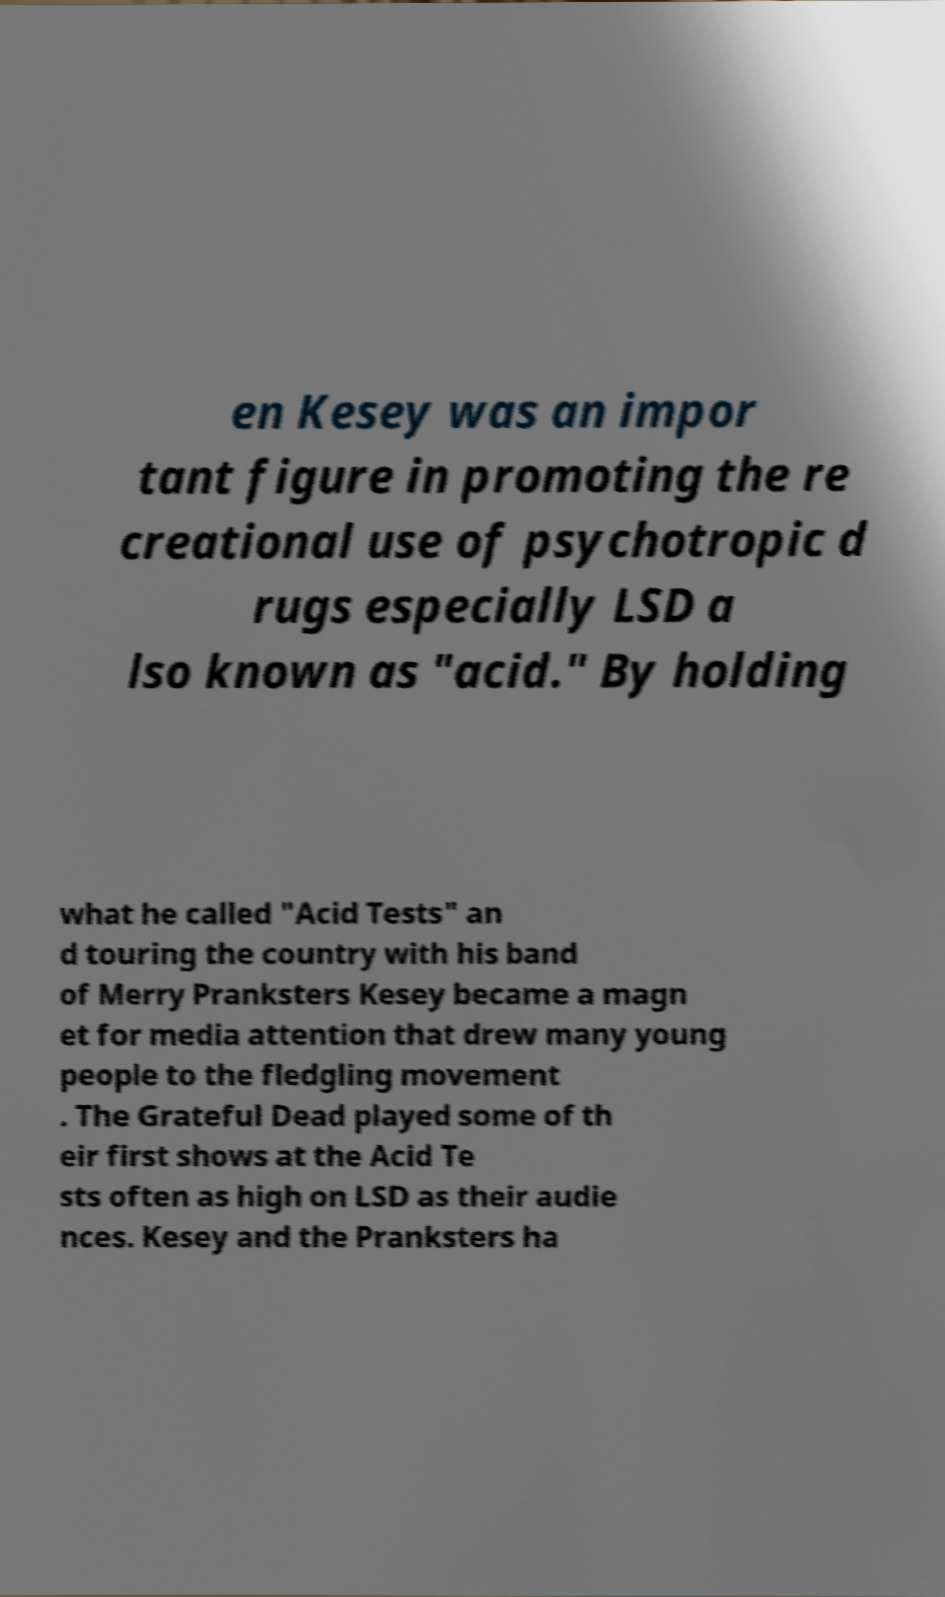Could you extract and type out the text from this image? en Kesey was an impor tant figure in promoting the re creational use of psychotropic d rugs especially LSD a lso known as "acid." By holding what he called "Acid Tests" an d touring the country with his band of Merry Pranksters Kesey became a magn et for media attention that drew many young people to the fledgling movement . The Grateful Dead played some of th eir first shows at the Acid Te sts often as high on LSD as their audie nces. Kesey and the Pranksters ha 